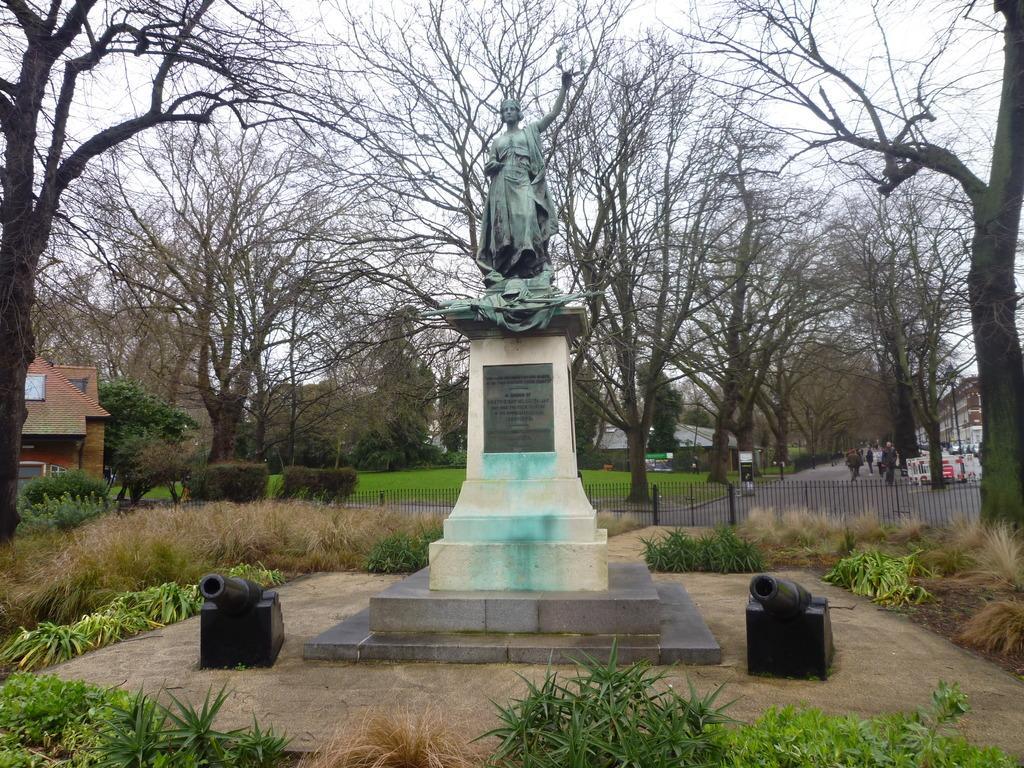How would you summarize this image in a sentence or two? In this image I can see the statue of the person. On both sides I can see the grass. In the background I can see the railing, boards and few people on the road. To the right I can see the pole. In the background I can see many trees, buildings and the sky. 